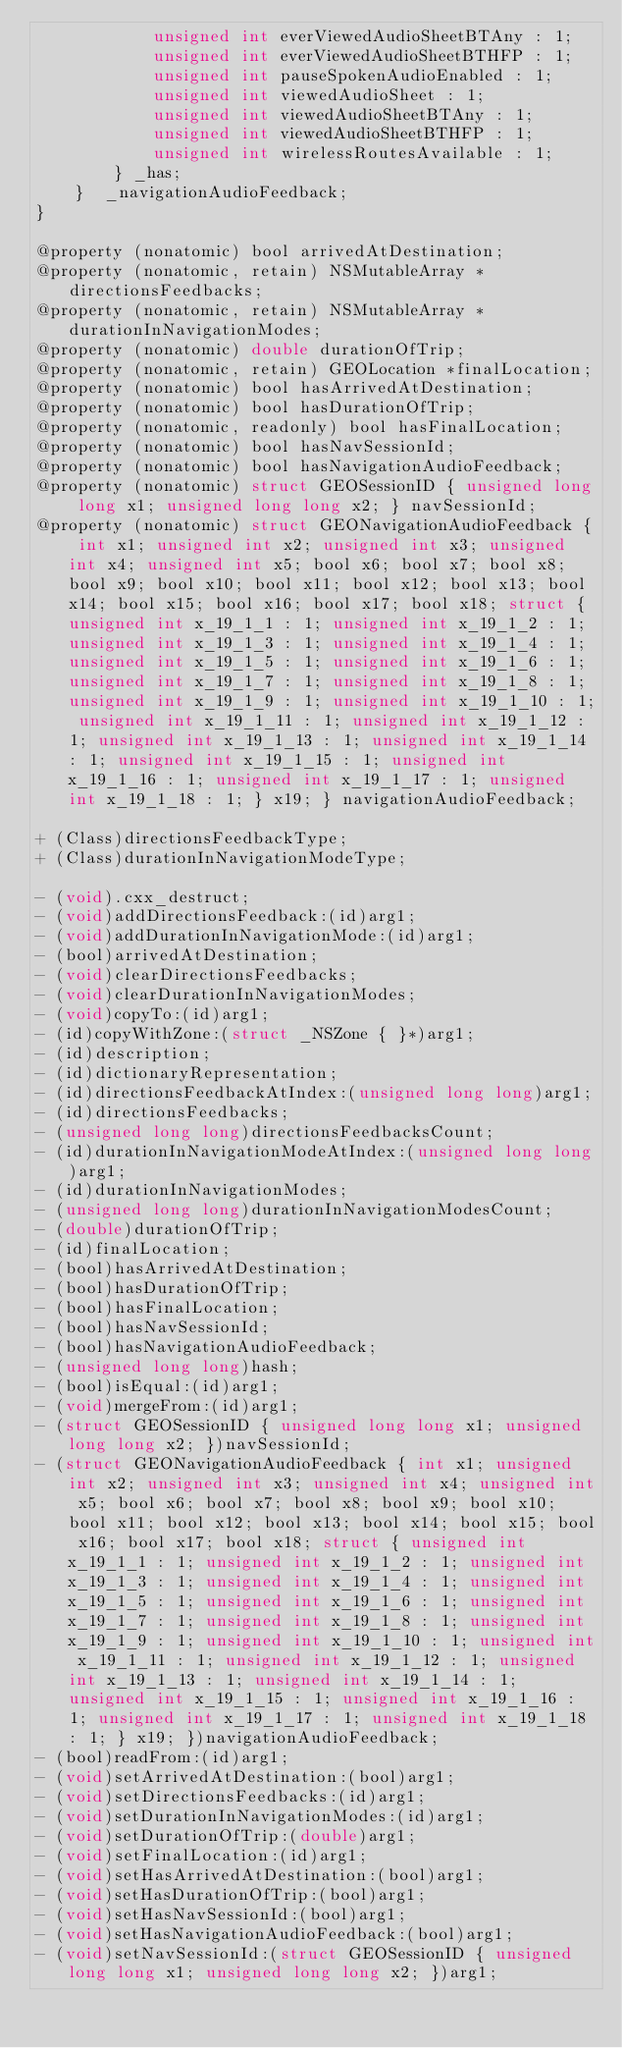<code> <loc_0><loc_0><loc_500><loc_500><_C_>            unsigned int everViewedAudioSheetBTAny : 1; 
            unsigned int everViewedAudioSheetBTHFP : 1; 
            unsigned int pauseSpokenAudioEnabled : 1; 
            unsigned int viewedAudioSheet : 1; 
            unsigned int viewedAudioSheetBTAny : 1; 
            unsigned int viewedAudioSheetBTHFP : 1; 
            unsigned int wirelessRoutesAvailable : 1; 
        } _has; 
    }  _navigationAudioFeedback;
}

@property (nonatomic) bool arrivedAtDestination;
@property (nonatomic, retain) NSMutableArray *directionsFeedbacks;
@property (nonatomic, retain) NSMutableArray *durationInNavigationModes;
@property (nonatomic) double durationOfTrip;
@property (nonatomic, retain) GEOLocation *finalLocation;
@property (nonatomic) bool hasArrivedAtDestination;
@property (nonatomic) bool hasDurationOfTrip;
@property (nonatomic, readonly) bool hasFinalLocation;
@property (nonatomic) bool hasNavSessionId;
@property (nonatomic) bool hasNavigationAudioFeedback;
@property (nonatomic) struct GEOSessionID { unsigned long long x1; unsigned long long x2; } navSessionId;
@property (nonatomic) struct GEONavigationAudioFeedback { int x1; unsigned int x2; unsigned int x3; unsigned int x4; unsigned int x5; bool x6; bool x7; bool x8; bool x9; bool x10; bool x11; bool x12; bool x13; bool x14; bool x15; bool x16; bool x17; bool x18; struct { unsigned int x_19_1_1 : 1; unsigned int x_19_1_2 : 1; unsigned int x_19_1_3 : 1; unsigned int x_19_1_4 : 1; unsigned int x_19_1_5 : 1; unsigned int x_19_1_6 : 1; unsigned int x_19_1_7 : 1; unsigned int x_19_1_8 : 1; unsigned int x_19_1_9 : 1; unsigned int x_19_1_10 : 1; unsigned int x_19_1_11 : 1; unsigned int x_19_1_12 : 1; unsigned int x_19_1_13 : 1; unsigned int x_19_1_14 : 1; unsigned int x_19_1_15 : 1; unsigned int x_19_1_16 : 1; unsigned int x_19_1_17 : 1; unsigned int x_19_1_18 : 1; } x19; } navigationAudioFeedback;

+ (Class)directionsFeedbackType;
+ (Class)durationInNavigationModeType;

- (void).cxx_destruct;
- (void)addDirectionsFeedback:(id)arg1;
- (void)addDurationInNavigationMode:(id)arg1;
- (bool)arrivedAtDestination;
- (void)clearDirectionsFeedbacks;
- (void)clearDurationInNavigationModes;
- (void)copyTo:(id)arg1;
- (id)copyWithZone:(struct _NSZone { }*)arg1;
- (id)description;
- (id)dictionaryRepresentation;
- (id)directionsFeedbackAtIndex:(unsigned long long)arg1;
- (id)directionsFeedbacks;
- (unsigned long long)directionsFeedbacksCount;
- (id)durationInNavigationModeAtIndex:(unsigned long long)arg1;
- (id)durationInNavigationModes;
- (unsigned long long)durationInNavigationModesCount;
- (double)durationOfTrip;
- (id)finalLocation;
- (bool)hasArrivedAtDestination;
- (bool)hasDurationOfTrip;
- (bool)hasFinalLocation;
- (bool)hasNavSessionId;
- (bool)hasNavigationAudioFeedback;
- (unsigned long long)hash;
- (bool)isEqual:(id)arg1;
- (void)mergeFrom:(id)arg1;
- (struct GEOSessionID { unsigned long long x1; unsigned long long x2; })navSessionId;
- (struct GEONavigationAudioFeedback { int x1; unsigned int x2; unsigned int x3; unsigned int x4; unsigned int x5; bool x6; bool x7; bool x8; bool x9; bool x10; bool x11; bool x12; bool x13; bool x14; bool x15; bool x16; bool x17; bool x18; struct { unsigned int x_19_1_1 : 1; unsigned int x_19_1_2 : 1; unsigned int x_19_1_3 : 1; unsigned int x_19_1_4 : 1; unsigned int x_19_1_5 : 1; unsigned int x_19_1_6 : 1; unsigned int x_19_1_7 : 1; unsigned int x_19_1_8 : 1; unsigned int x_19_1_9 : 1; unsigned int x_19_1_10 : 1; unsigned int x_19_1_11 : 1; unsigned int x_19_1_12 : 1; unsigned int x_19_1_13 : 1; unsigned int x_19_1_14 : 1; unsigned int x_19_1_15 : 1; unsigned int x_19_1_16 : 1; unsigned int x_19_1_17 : 1; unsigned int x_19_1_18 : 1; } x19; })navigationAudioFeedback;
- (bool)readFrom:(id)arg1;
- (void)setArrivedAtDestination:(bool)arg1;
- (void)setDirectionsFeedbacks:(id)arg1;
- (void)setDurationInNavigationModes:(id)arg1;
- (void)setDurationOfTrip:(double)arg1;
- (void)setFinalLocation:(id)arg1;
- (void)setHasArrivedAtDestination:(bool)arg1;
- (void)setHasDurationOfTrip:(bool)arg1;
- (void)setHasNavSessionId:(bool)arg1;
- (void)setHasNavigationAudioFeedback:(bool)arg1;
- (void)setNavSessionId:(struct GEOSessionID { unsigned long long x1; unsigned long long x2; })arg1;</code> 